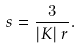<formula> <loc_0><loc_0><loc_500><loc_500>s = \frac { 3 } { \left | K \right | r } .</formula> 